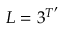<formula> <loc_0><loc_0><loc_500><loc_500>L = 3 ^ { T ^ { \prime } }</formula> 